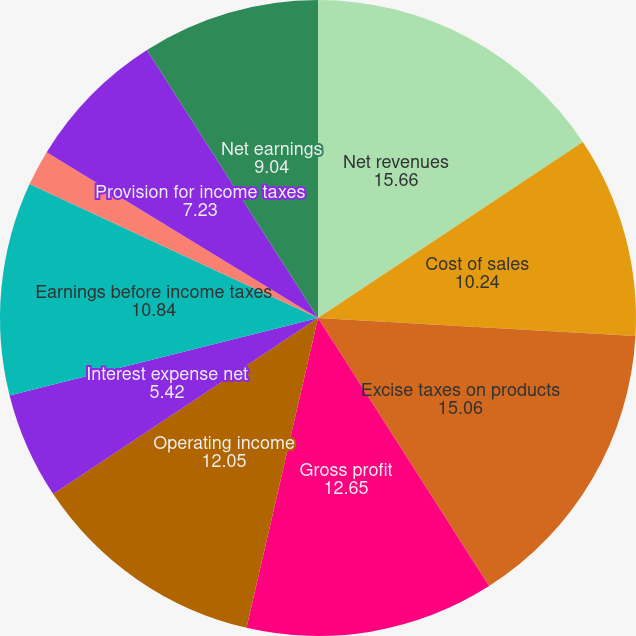<chart> <loc_0><loc_0><loc_500><loc_500><pie_chart><fcel>Net revenues<fcel>Cost of sales<fcel>Excise taxes on products<fcel>Gross profit<fcel>Operating income<fcel>Interest expense net<fcel>Earnings before income taxes<fcel>Pre-tax profit margin<fcel>Provision for income taxes<fcel>Net earnings<nl><fcel>15.66%<fcel>10.24%<fcel>15.06%<fcel>12.65%<fcel>12.05%<fcel>5.42%<fcel>10.84%<fcel>1.81%<fcel>7.23%<fcel>9.04%<nl></chart> 